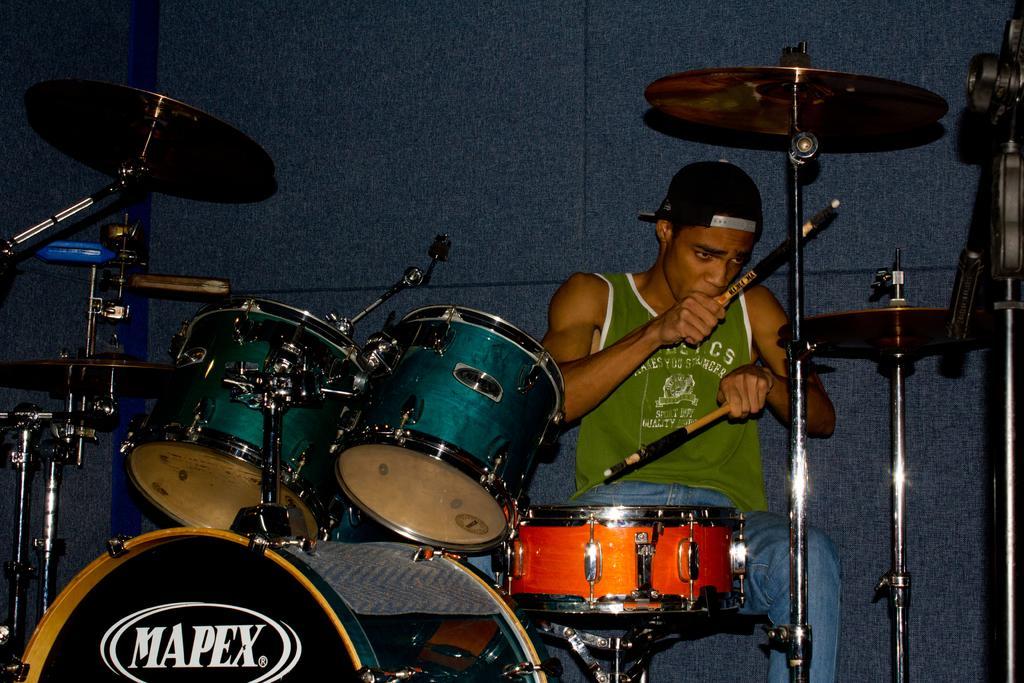How would you summarize this image in a sentence or two? This picture shows man seated and playing drums with sticks in his hands and he wore a cap on his head and we see a wall on the back. He wore a green sleeveless t-shirt and a blue jeans. 